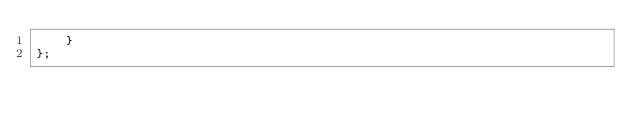Convert code to text. <code><loc_0><loc_0><loc_500><loc_500><_JavaScript_>	}
};
</code> 